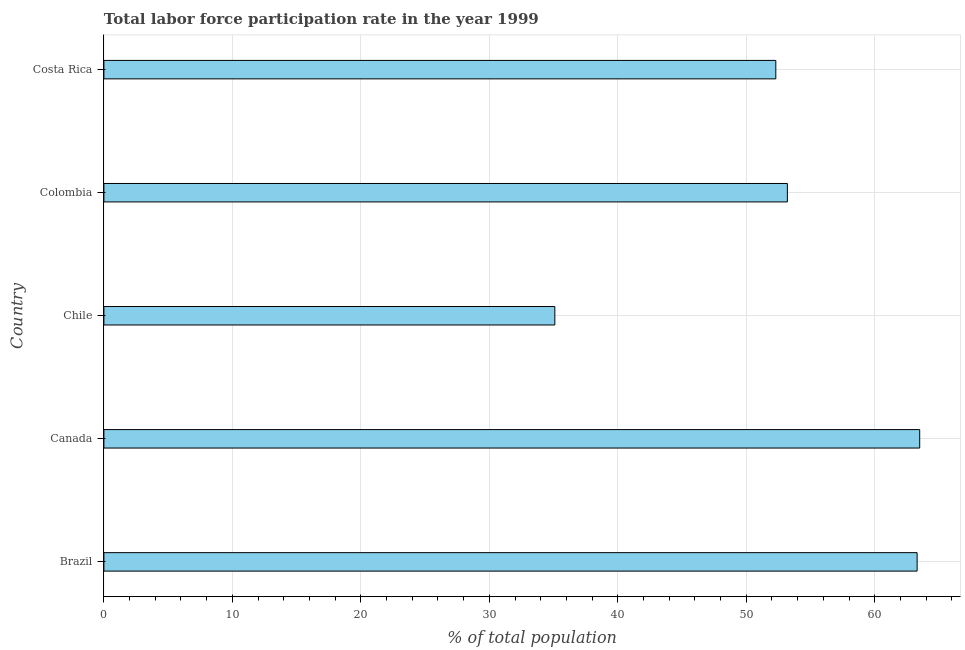What is the title of the graph?
Ensure brevity in your answer.  Total labor force participation rate in the year 1999. What is the label or title of the X-axis?
Ensure brevity in your answer.  % of total population. What is the label or title of the Y-axis?
Provide a succinct answer. Country. What is the total labor force participation rate in Canada?
Ensure brevity in your answer.  63.5. Across all countries, what is the maximum total labor force participation rate?
Make the answer very short. 63.5. Across all countries, what is the minimum total labor force participation rate?
Provide a succinct answer. 35.1. In which country was the total labor force participation rate maximum?
Provide a succinct answer. Canada. In which country was the total labor force participation rate minimum?
Give a very brief answer. Chile. What is the sum of the total labor force participation rate?
Provide a succinct answer. 267.4. What is the difference between the total labor force participation rate in Canada and Chile?
Your answer should be very brief. 28.4. What is the average total labor force participation rate per country?
Your answer should be compact. 53.48. What is the median total labor force participation rate?
Provide a short and direct response. 53.2. In how many countries, is the total labor force participation rate greater than 48 %?
Your response must be concise. 4. What is the ratio of the total labor force participation rate in Canada to that in Chile?
Give a very brief answer. 1.81. What is the difference between the highest and the second highest total labor force participation rate?
Your answer should be very brief. 0.2. Is the sum of the total labor force participation rate in Canada and Colombia greater than the maximum total labor force participation rate across all countries?
Your response must be concise. Yes. What is the difference between the highest and the lowest total labor force participation rate?
Provide a succinct answer. 28.4. How many bars are there?
Give a very brief answer. 5. Are all the bars in the graph horizontal?
Your answer should be very brief. Yes. What is the difference between two consecutive major ticks on the X-axis?
Give a very brief answer. 10. What is the % of total population of Brazil?
Offer a terse response. 63.3. What is the % of total population in Canada?
Offer a very short reply. 63.5. What is the % of total population of Chile?
Provide a succinct answer. 35.1. What is the % of total population in Colombia?
Give a very brief answer. 53.2. What is the % of total population of Costa Rica?
Your response must be concise. 52.3. What is the difference between the % of total population in Brazil and Chile?
Offer a very short reply. 28.2. What is the difference between the % of total population in Brazil and Colombia?
Give a very brief answer. 10.1. What is the difference between the % of total population in Brazil and Costa Rica?
Keep it short and to the point. 11. What is the difference between the % of total population in Canada and Chile?
Give a very brief answer. 28.4. What is the difference between the % of total population in Canada and Costa Rica?
Your answer should be very brief. 11.2. What is the difference between the % of total population in Chile and Colombia?
Your answer should be compact. -18.1. What is the difference between the % of total population in Chile and Costa Rica?
Your answer should be very brief. -17.2. What is the difference between the % of total population in Colombia and Costa Rica?
Ensure brevity in your answer.  0.9. What is the ratio of the % of total population in Brazil to that in Chile?
Ensure brevity in your answer.  1.8. What is the ratio of the % of total population in Brazil to that in Colombia?
Make the answer very short. 1.19. What is the ratio of the % of total population in Brazil to that in Costa Rica?
Your answer should be compact. 1.21. What is the ratio of the % of total population in Canada to that in Chile?
Your answer should be very brief. 1.81. What is the ratio of the % of total population in Canada to that in Colombia?
Your answer should be very brief. 1.19. What is the ratio of the % of total population in Canada to that in Costa Rica?
Your answer should be compact. 1.21. What is the ratio of the % of total population in Chile to that in Colombia?
Provide a short and direct response. 0.66. What is the ratio of the % of total population in Chile to that in Costa Rica?
Offer a very short reply. 0.67. 